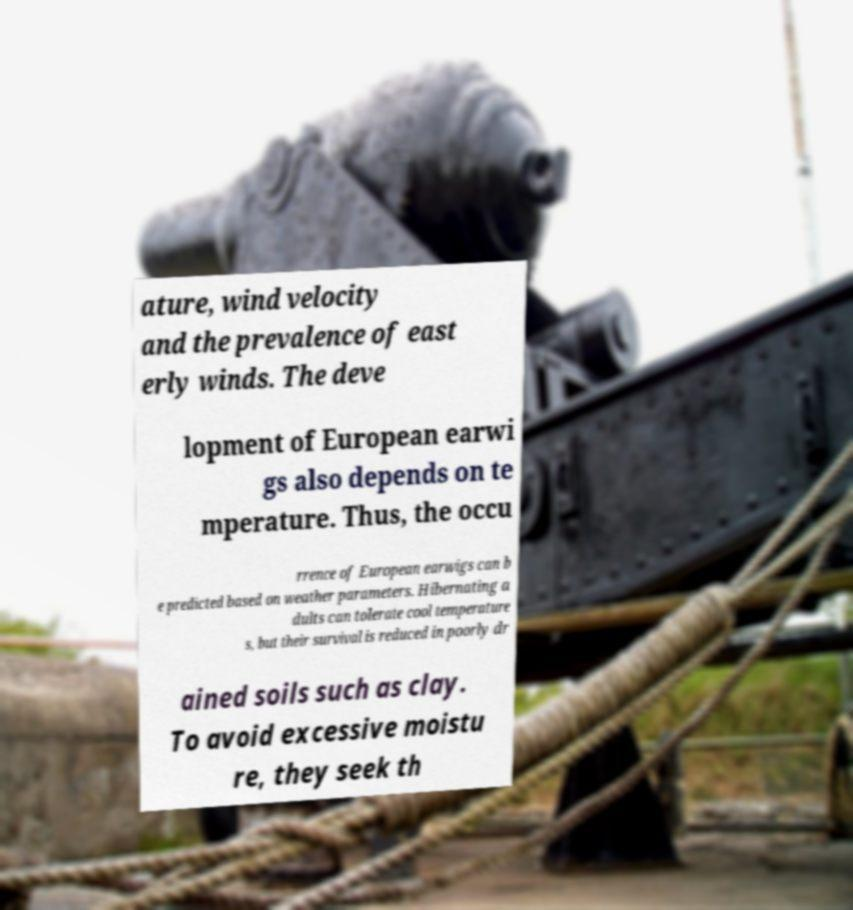Could you extract and type out the text from this image? ature, wind velocity and the prevalence of east erly winds. The deve lopment of European earwi gs also depends on te mperature. Thus, the occu rrence of European earwigs can b e predicted based on weather parameters. Hibernating a dults can tolerate cool temperature s, but their survival is reduced in poorly dr ained soils such as clay. To avoid excessive moistu re, they seek th 